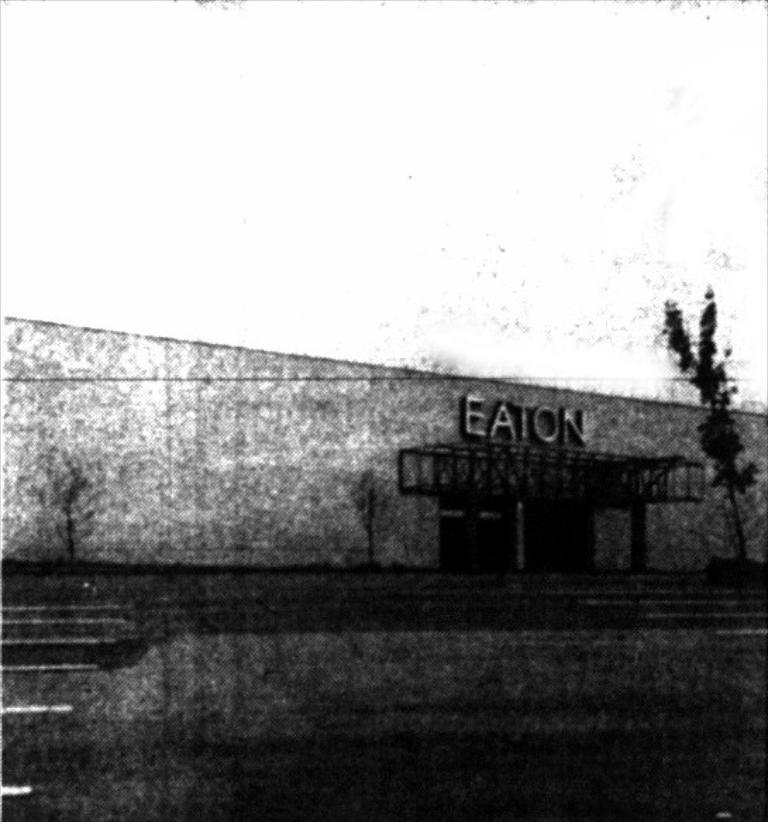Provide a one-sentence caption for the provided image. Crackly, damaged and fuzzy its hard to tell if this is Eaton station pictured or some other industrial unit. 